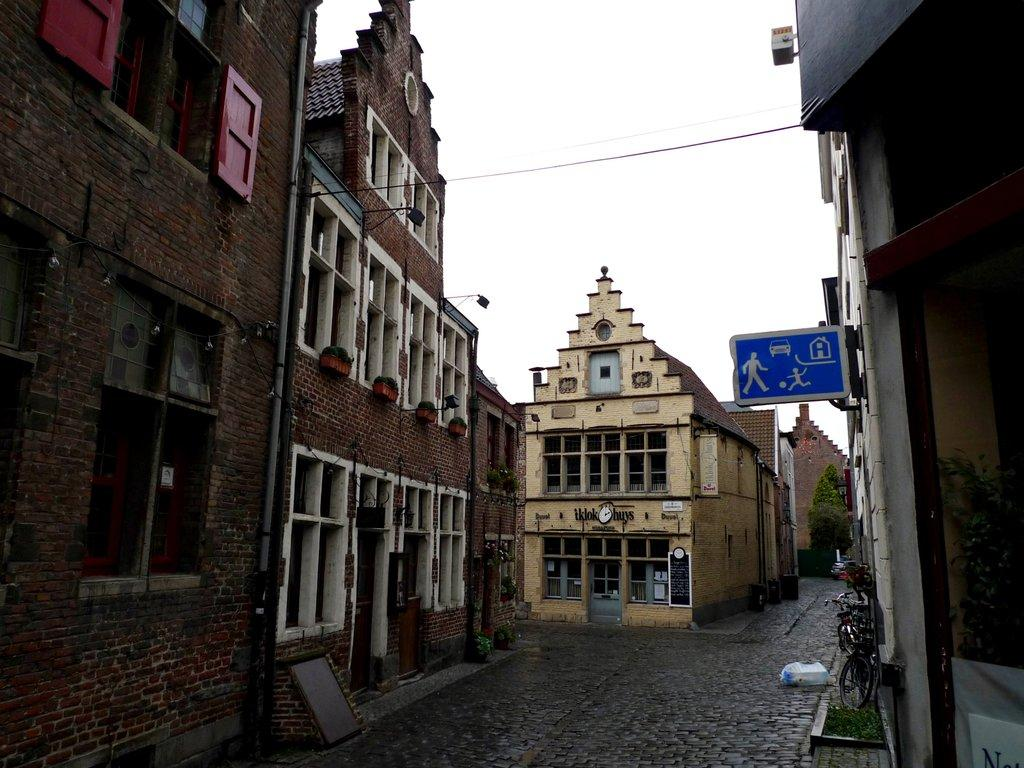What type of structure is present in the image? There is a building in the image. What architectural features can be seen on the building? The building has windows and pillars. What is located near the building? There are cycles near the building. What can be seen in the background of the image? The sky is visible in the background of the image. What hobbies do the fish in the image enjoy? There are no fish present in the image, so we cannot determine their hobbies. How does the air affect the building in the image? The air does not have a direct effect on the building in the image; it is simply visible in the background. 